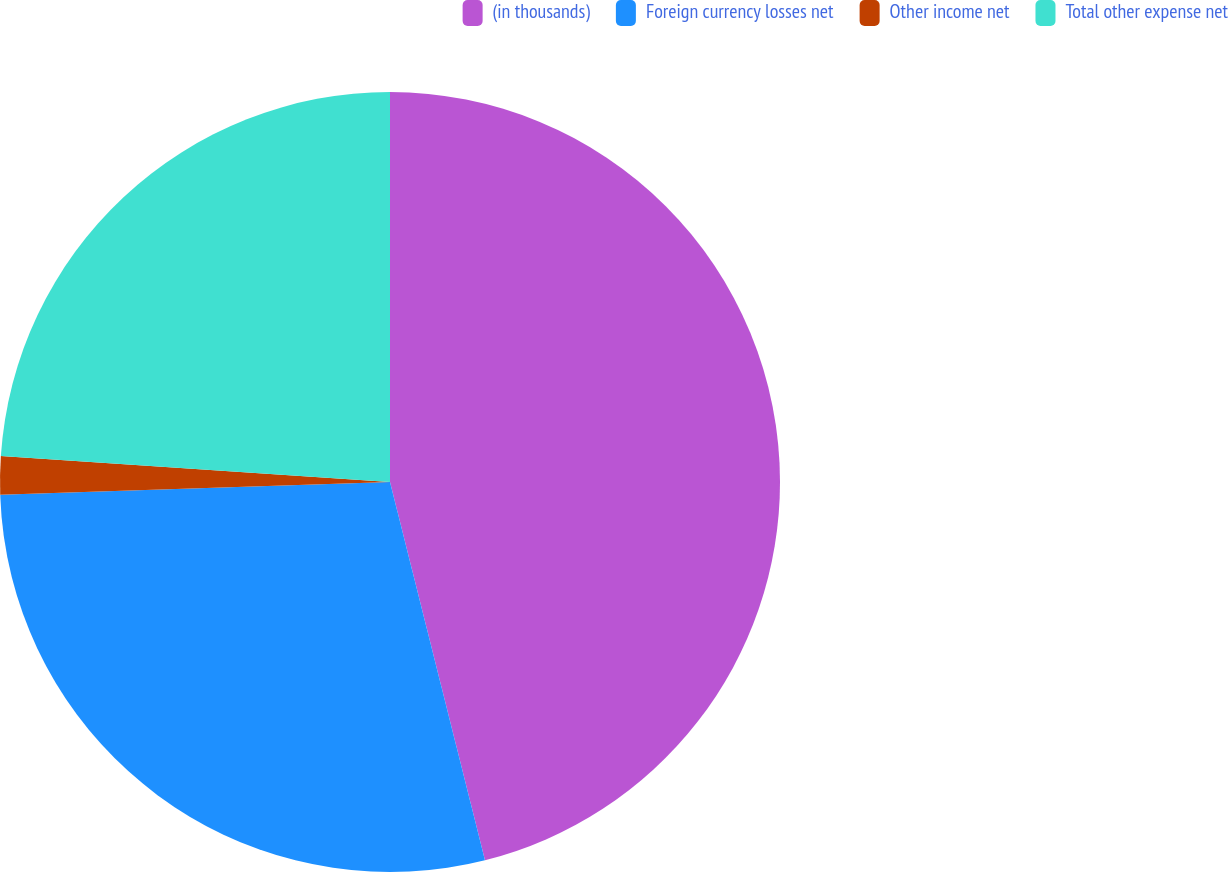<chart> <loc_0><loc_0><loc_500><loc_500><pie_chart><fcel>(in thousands)<fcel>Foreign currency losses net<fcel>Other income net<fcel>Total other expense net<nl><fcel>46.08%<fcel>28.39%<fcel>1.58%<fcel>23.94%<nl></chart> 